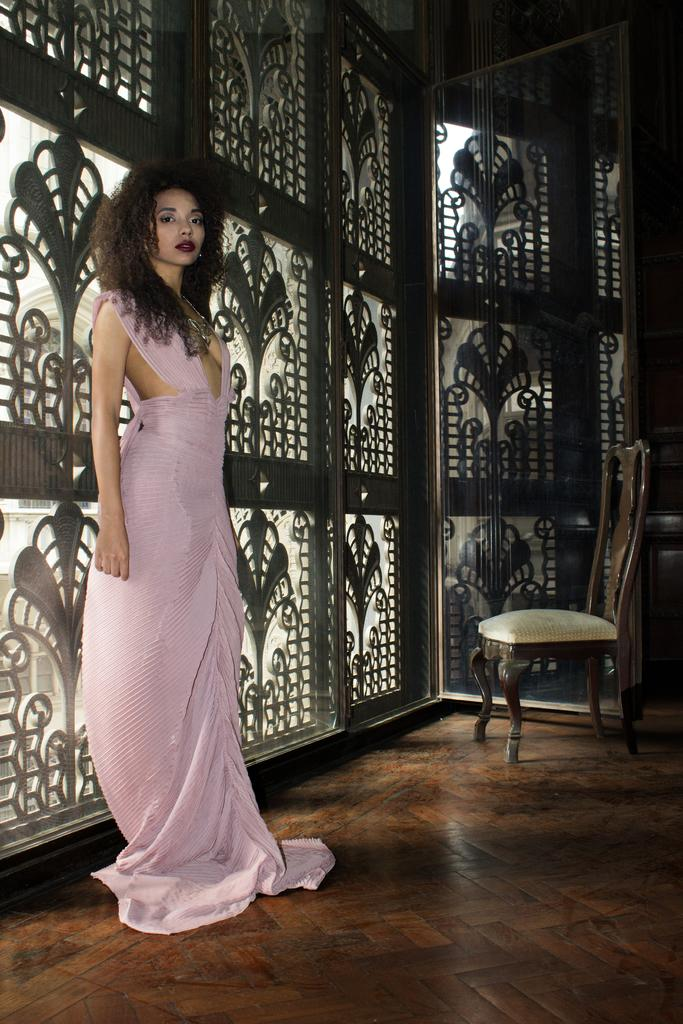Who is present in the image? There is a woman in the image. What is the woman doing in the image? The woman is standing on the floor. What can be seen on the wall behind the woman? There is a design on the wall behind the woman. What is in front of the woman? There is a chair in front of the woman. How many bikes are visible in the image? There are no bikes present in the image. What type of sand can be seen on the floor in the image? There is no sand visible on the floor in the image. 